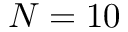<formula> <loc_0><loc_0><loc_500><loc_500>N = 1 0</formula> 